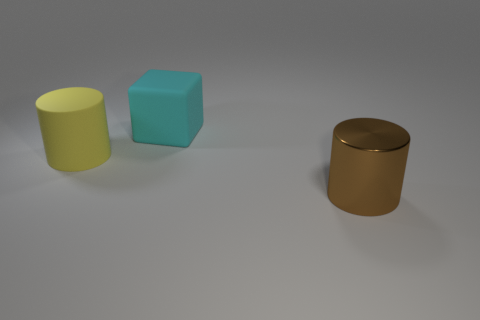How many other objects are the same shape as the brown object?
Offer a terse response. 1. There is a big cylinder that is to the left of the big brown metallic cylinder; does it have the same color as the object that is right of the large matte cube?
Your response must be concise. No. What number of tiny objects are shiny cylinders or purple cubes?
Offer a very short reply. 0. There is a yellow matte object that is the same shape as the shiny object; what size is it?
Offer a very short reply. Large. Is there any other thing that has the same size as the yellow cylinder?
Provide a succinct answer. Yes. The large cylinder that is on the left side of the big cylinder that is in front of the big rubber cylinder is made of what material?
Keep it short and to the point. Rubber. How many rubber objects are either small red things or yellow cylinders?
Give a very brief answer. 1. There is a rubber object that is the same shape as the big metal object; what color is it?
Keep it short and to the point. Yellow. How many cubes have the same color as the big metal thing?
Provide a short and direct response. 0. There is a object that is left of the cyan cube; are there any matte cubes on the left side of it?
Provide a short and direct response. No. 